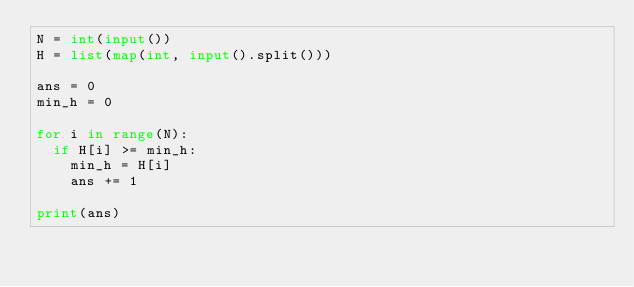<code> <loc_0><loc_0><loc_500><loc_500><_Python_>N = int(input())
H = list(map(int, input().split()))

ans = 0
min_h = 0

for i in range(N):
  if H[i] >= min_h:
    min_h = H[i]
    ans += 1
    
print(ans)</code> 